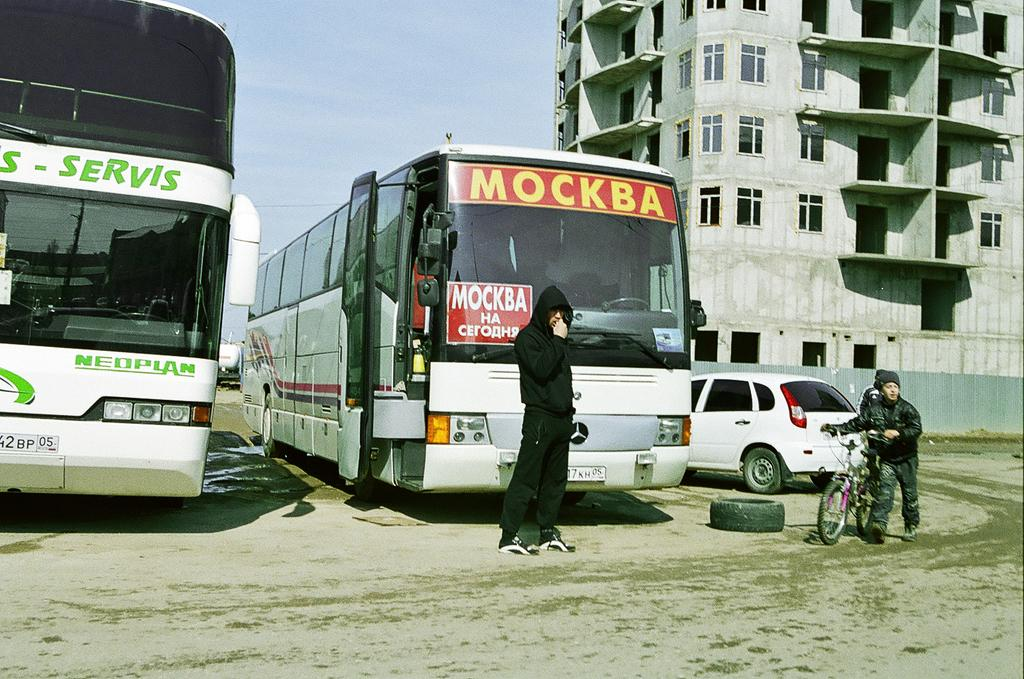<image>
Provide a brief description of the given image. Two buses side by side with one bearing the word Mockba. 